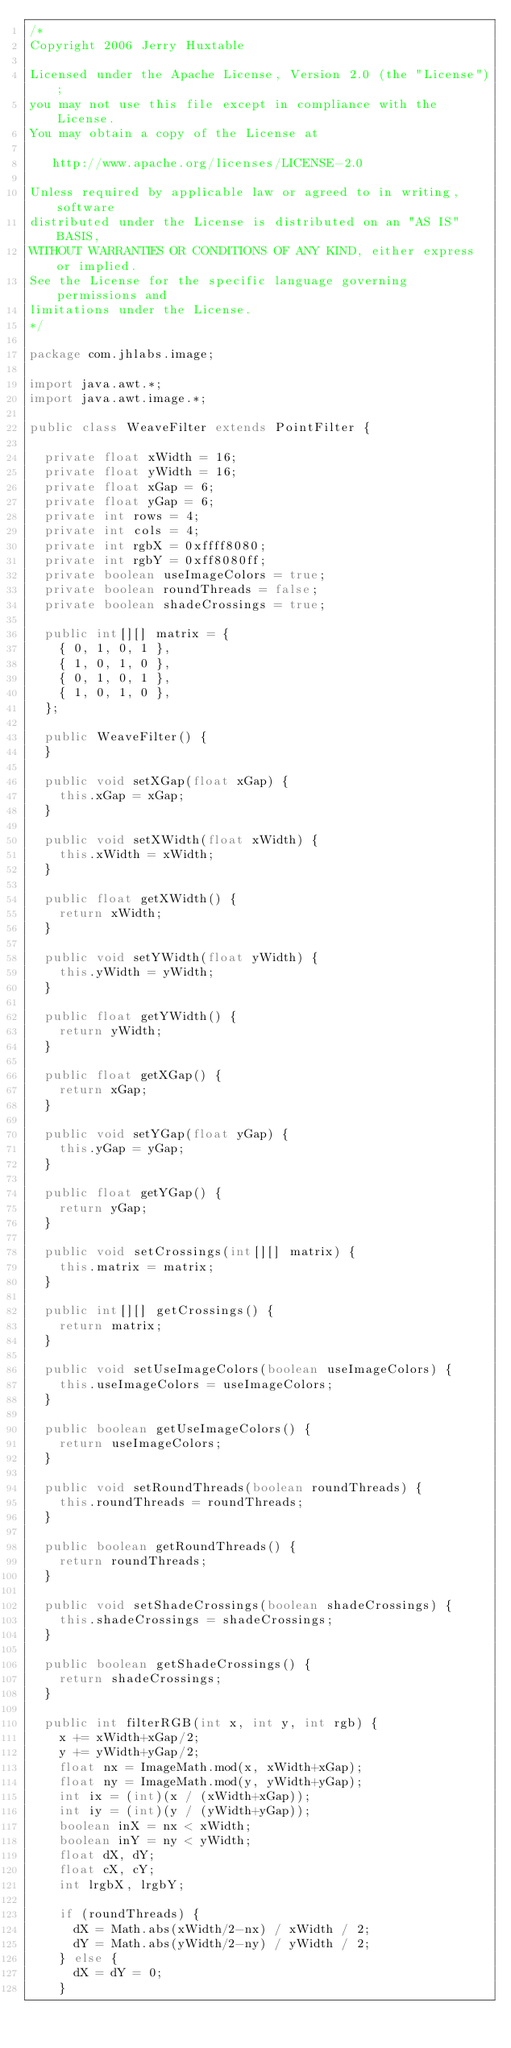Convert code to text. <code><loc_0><loc_0><loc_500><loc_500><_Java_>/*
Copyright 2006 Jerry Huxtable

Licensed under the Apache License, Version 2.0 (the "License");
you may not use this file except in compliance with the License.
You may obtain a copy of the License at

   http://www.apache.org/licenses/LICENSE-2.0

Unless required by applicable law or agreed to in writing, software
distributed under the License is distributed on an "AS IS" BASIS,
WITHOUT WARRANTIES OR CONDITIONS OF ANY KIND, either express or implied.
See the License for the specific language governing permissions and
limitations under the License.
*/

package com.jhlabs.image;

import java.awt.*;
import java.awt.image.*;

public class WeaveFilter extends PointFilter {

	private float xWidth = 16;
	private float yWidth = 16;
	private float xGap = 6;
	private float yGap = 6;
	private int rows = 4;
	private int cols = 4;
	private int rgbX = 0xffff8080;
	private int rgbY = 0xff8080ff;
	private boolean useImageColors = true;
	private boolean roundThreads = false;
	private boolean shadeCrossings = true;

	public int[][] matrix = {
		{ 0, 1, 0, 1 },
		{ 1, 0, 1, 0 },
		{ 0, 1, 0, 1 },
		{ 1, 0, 1, 0 },
	};
	
	public WeaveFilter() {
	}
	
	public void setXGap(float xGap) {
		this.xGap = xGap;
	}

	public void setXWidth(float xWidth) {
		this.xWidth = xWidth;
	}

	public float getXWidth() {
		return xWidth;
	}

	public void setYWidth(float yWidth) {
		this.yWidth = yWidth;
	}

	public float getYWidth() {
		return yWidth;
	}

	public float getXGap() {
		return xGap;
	}

	public void setYGap(float yGap) {
		this.yGap = yGap;
	}

	public float getYGap() {
		return yGap;
	}

	public void setCrossings(int[][] matrix) {
		this.matrix = matrix;
	}
	
	public int[][] getCrossings() {
		return matrix;
	}
	
	public void setUseImageColors(boolean useImageColors) {
		this.useImageColors = useImageColors;
	}

	public boolean getUseImageColors() {
		return useImageColors;
	}

	public void setRoundThreads(boolean roundThreads) {
		this.roundThreads = roundThreads;
	}

	public boolean getRoundThreads() {
		return roundThreads;
	}

	public void setShadeCrossings(boolean shadeCrossings) {
		this.shadeCrossings = shadeCrossings;
	}

	public boolean getShadeCrossings() {
		return shadeCrossings;
	}

	public int filterRGB(int x, int y, int rgb) {
		x += xWidth+xGap/2;
		y += yWidth+yGap/2;
		float nx = ImageMath.mod(x, xWidth+xGap);
		float ny = ImageMath.mod(y, yWidth+yGap);
		int ix = (int)(x / (xWidth+xGap));
		int iy = (int)(y / (yWidth+yGap));
		boolean inX = nx < xWidth;
		boolean inY = ny < yWidth;
		float dX, dY;
		float cX, cY;
		int lrgbX, lrgbY;

		if (roundThreads) {
			dX = Math.abs(xWidth/2-nx) / xWidth / 2;
			dY = Math.abs(yWidth/2-ny) / yWidth / 2;
		} else {
			dX = dY = 0;
		}
</code> 